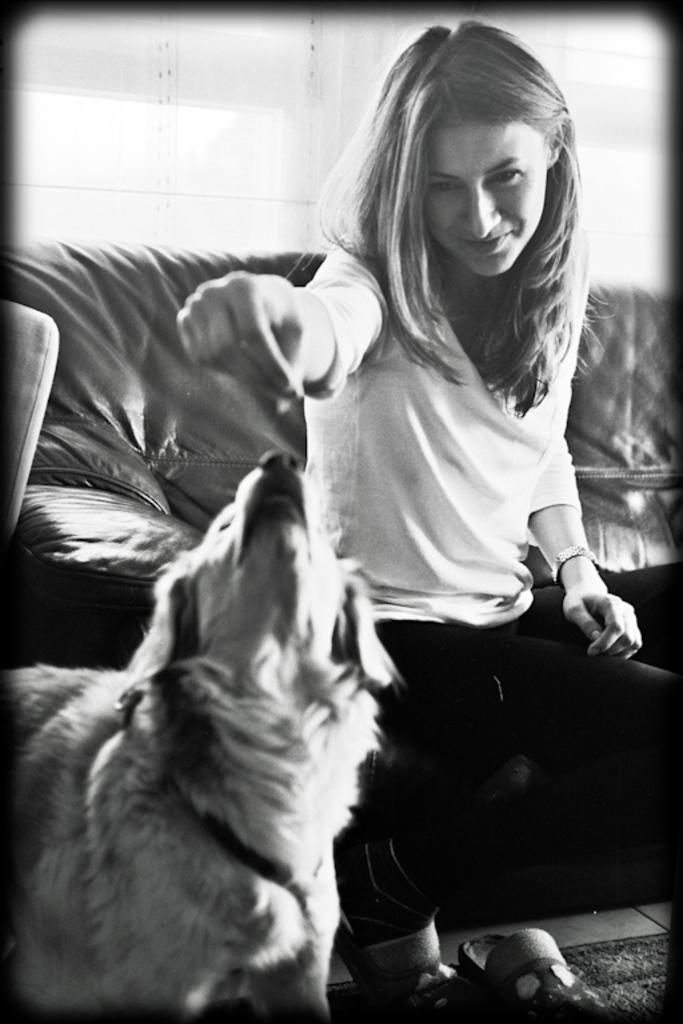What is the color scheme of the image? The image is black and white. Who is present in the image? There is a woman in the image. What is the woman doing in the image? The woman is sitting on a couch and smiling. What is the woman holding in the image? The woman is holding an object. Can you describe the presence of any animals in the image? There is a dog on the left side bottom of the image. What type of wood is the woman using to build a train in the image? There is no wood or train present in the image. Is the woman wearing a crown in the image? There is no crown visible in the image. 